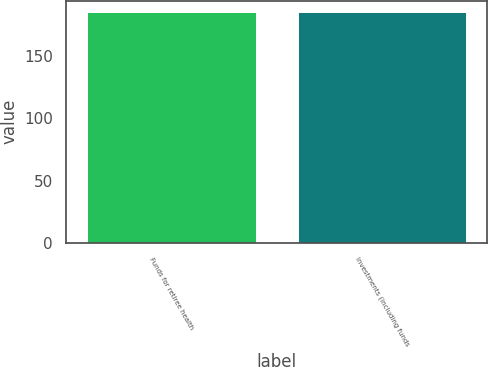Convert chart to OTSL. <chart><loc_0><loc_0><loc_500><loc_500><bar_chart><fcel>Funds for retiree health<fcel>Investments (including funds<nl><fcel>185<fcel>185.1<nl></chart> 